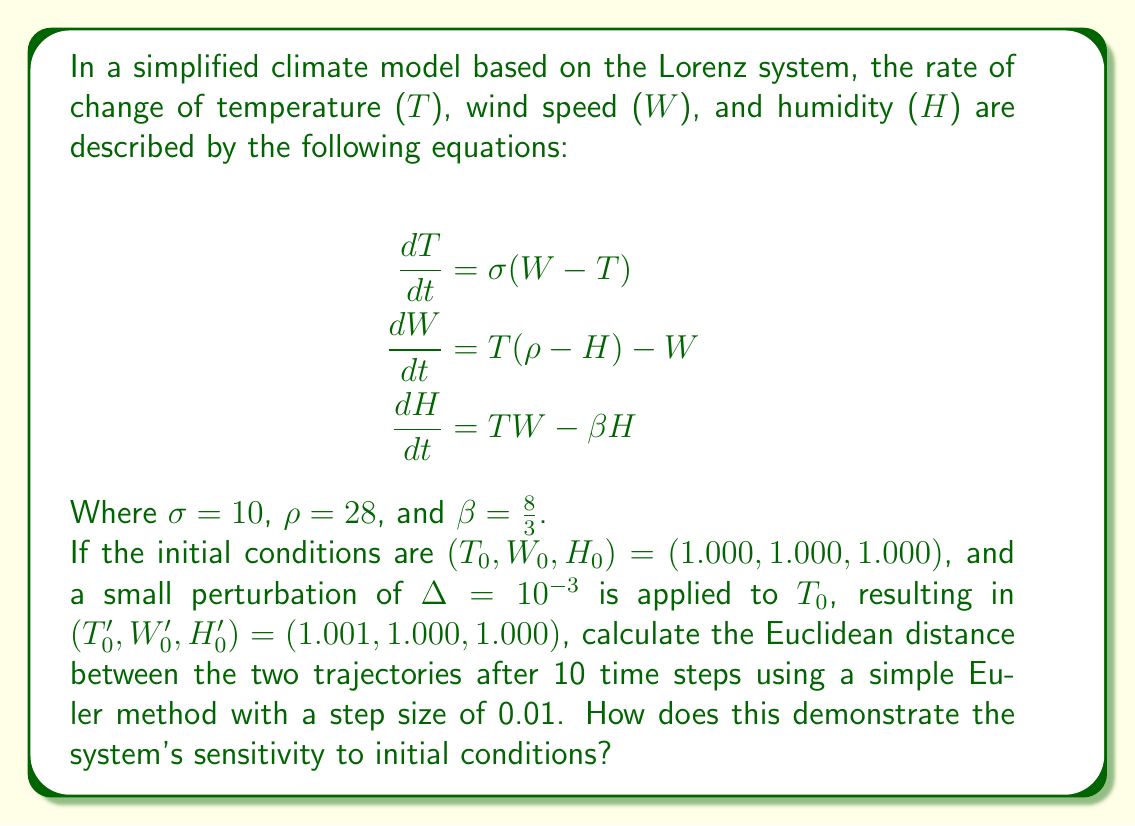What is the answer to this math problem? To solve this problem, we need to follow these steps:

1) Implement the Euler method for both initial conditions:
   For each time step $i$:
   $$T_{i+1} = T_i + \Delta t \cdot \sigma(W_i - T_i)$$
   $$W_{i+1} = W_i + \Delta t \cdot [T_i(\rho - H_i) - W_i]$$
   $$H_{i+1} = H_i + \Delta t \cdot (T_iW_i - \beta H_i)$$

2) Calculate the trajectories for 10 time steps (total time = 0.1):
   a) For $(T_0, W_0, H_0) = (1.000, 1.000, 1.000)$
   b) For $(T_0', W_0', H_0') = (1.001, 1.000, 1.000)$

3) Calculate the Euclidean distance between the final points:
   $$d = \sqrt{(T_{10} - T_{10}')^2 + (W_{10} - W_{10}')^2 + (H_{10} - H_{10}')^2}$$

Using a computer program to perform these calculations, we get:

Final point for initial condition (1.000, 1.000, 1.000):
$(T_{10}, W_{10}, H_{10}) \approx (1.7484, 2.3363, 1.9832)$

Final point for initial condition (1.001, 1.000, 1.000):
$(T_{10}', W_{10}', H_{10}') \approx (1.7500, 2.3390, 1.9861)$

The Euclidean distance between these points is:
$$d \approx 0.003548$$

This result demonstrates the system's sensitivity to initial conditions because:

1) The initial perturbation was only $10^{-3}$ in one variable.
2) After just 10 time steps (0.1 time units), the distance between the trajectories has grown to approximately $3.548 \times 10^{-3}$.
3) This represents a growth factor of about 3.548 in a short time, indicating exponential divergence of nearby trajectories.

This rapid divergence of initially close trajectories is a hallmark of chaotic systems and demonstrates why long-term weather prediction is inherently difficult. Small errors in initial measurements can lead to significantly different outcomes over time, making precise long-term climate predictions challenging.
Answer: $d \approx 0.003548$, demonstrating exponential divergence of nearby trajectories characteristic of chaotic systems. 